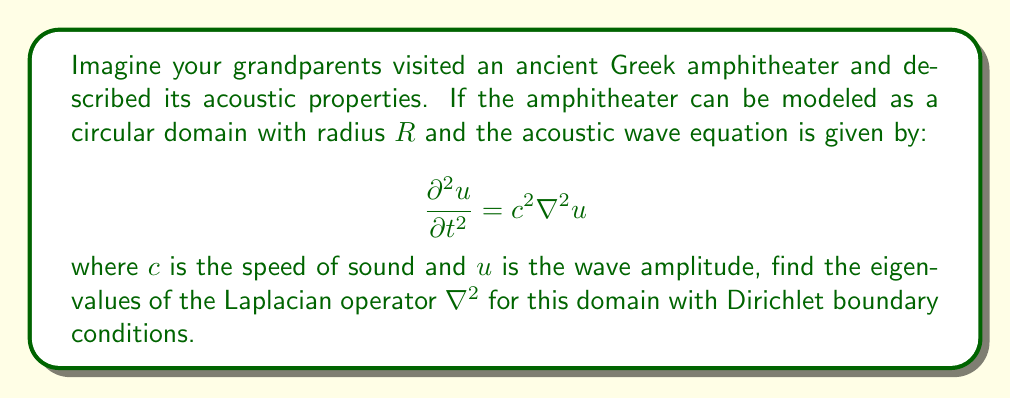Provide a solution to this math problem. 1) First, we need to express the Laplacian in polar coordinates:

   $$\nabla^2 u = \frac{1}{r}\frac{\partial}{\partial r}\left(r\frac{\partial u}{\partial r}\right) + \frac{1}{r^2}\frac{\partial^2 u}{\partial \theta^2}$$

2) The eigenvalue problem is:

   $$\nabla^2 u = -\lambda u$$

3) We can separate variables: $u(r,\theta) = R(r)\Theta(\theta)$

4) This leads to two equations:

   $$\frac{d^2\Theta}{d\theta^2} = -m^2\Theta$$
   $$\frac{d^2R}{dr^2} + \frac{1}{r}\frac{dR}{dr} + \left(\lambda - \frac{m^2}{r^2}\right)R = 0$$

5) The solution for $\Theta$ is $\Theta(\theta) = A\cos(m\theta) + B\sin(m\theta)$, where $m$ is an integer.

6) The radial equation is a Bessel equation. With Dirichlet boundary conditions $R(R) = 0$, the solution is:

   $$R(r) = J_m(\sqrt{\lambda}r)$$

   where $J_m$ is the Bessel function of the first kind of order $m$.

7) The boundary condition requires:

   $$J_m(\sqrt{\lambda}R) = 0$$

8) Let $\alpha_{mn}$ be the nth zero of $J_m$. Then:

   $$\sqrt{\lambda}R = \alpha_{mn}$$

9) Therefore, the eigenvalues are:

   $$\lambda_{mn} = \frac{\alpha_{mn}^2}{R^2}$$

   where $m = 0, 1, 2, ...$ and $n = 1, 2, 3, ...$
Answer: $\lambda_{mn} = \frac{\alpha_{mn}^2}{R^2}$ 